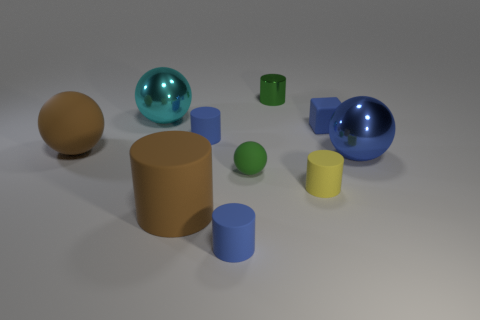Subtract all green cylinders. How many cylinders are left? 4 Subtract all small rubber spheres. How many spheres are left? 3 Subtract all yellow balls. Subtract all green blocks. How many balls are left? 4 Subtract all balls. How many objects are left? 6 Subtract 0 cyan cylinders. How many objects are left? 10 Subtract all large green metallic cubes. Subtract all large blue metal spheres. How many objects are left? 9 Add 3 blue balls. How many blue balls are left? 4 Add 2 shiny things. How many shiny things exist? 5 